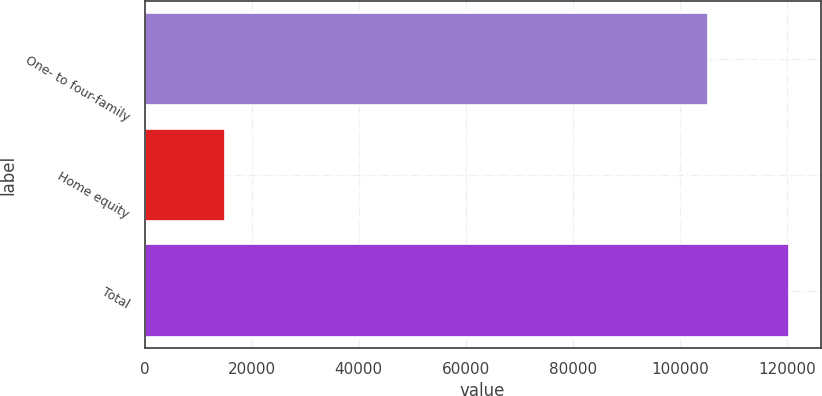Convert chart. <chart><loc_0><loc_0><loc_500><loc_500><bar_chart><fcel>One- to four-family<fcel>Home equity<fcel>Total<nl><fcel>105142<fcel>15107<fcel>120249<nl></chart> 